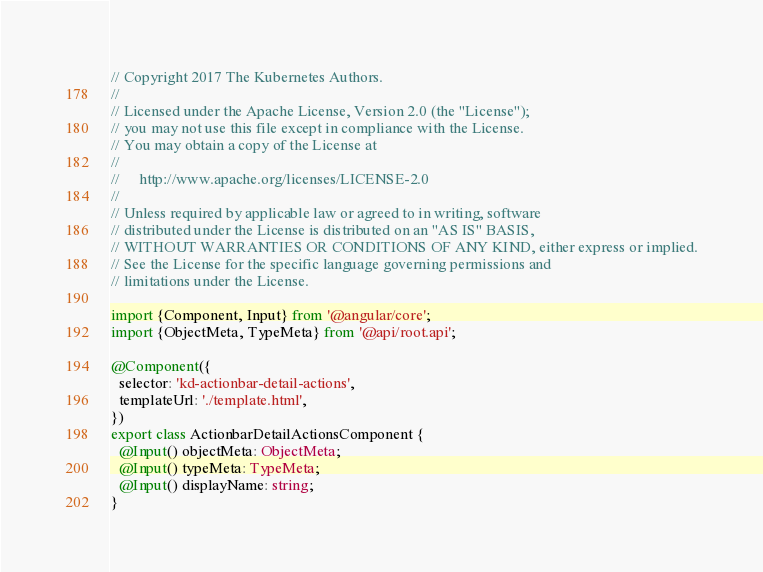Convert code to text. <code><loc_0><loc_0><loc_500><loc_500><_TypeScript_>// Copyright 2017 The Kubernetes Authors.
//
// Licensed under the Apache License, Version 2.0 (the "License");
// you may not use this file except in compliance with the License.
// You may obtain a copy of the License at
//
//     http://www.apache.org/licenses/LICENSE-2.0
//
// Unless required by applicable law or agreed to in writing, software
// distributed under the License is distributed on an "AS IS" BASIS,
// WITHOUT WARRANTIES OR CONDITIONS OF ANY KIND, either express or implied.
// See the License for the specific language governing permissions and
// limitations under the License.

import {Component, Input} from '@angular/core';
import {ObjectMeta, TypeMeta} from '@api/root.api';

@Component({
  selector: 'kd-actionbar-detail-actions',
  templateUrl: './template.html',
})
export class ActionbarDetailActionsComponent {
  @Input() objectMeta: ObjectMeta;
  @Input() typeMeta: TypeMeta;
  @Input() displayName: string;
}
</code> 